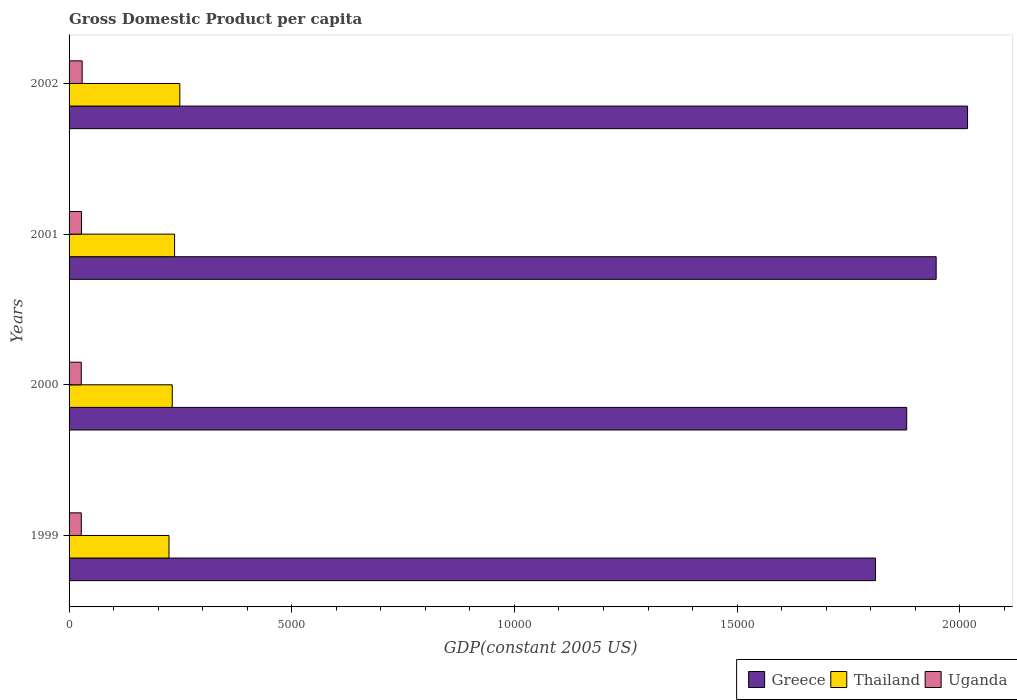How many different coloured bars are there?
Make the answer very short. 3. Are the number of bars per tick equal to the number of legend labels?
Offer a terse response. Yes. How many bars are there on the 4th tick from the top?
Keep it short and to the point. 3. What is the label of the 3rd group of bars from the top?
Offer a very short reply. 2000. In how many cases, is the number of bars for a given year not equal to the number of legend labels?
Provide a succinct answer. 0. What is the GDP per capita in Uganda in 1999?
Your response must be concise. 274.43. Across all years, what is the maximum GDP per capita in Uganda?
Your response must be concise. 293.98. Across all years, what is the minimum GDP per capita in Greece?
Your response must be concise. 1.81e+04. In which year was the GDP per capita in Uganda minimum?
Offer a terse response. 2000. What is the total GDP per capita in Greece in the graph?
Give a very brief answer. 7.66e+04. What is the difference between the GDP per capita in Greece in 2000 and that in 2001?
Offer a very short reply. -661.74. What is the difference between the GDP per capita in Uganda in 1999 and the GDP per capita in Thailand in 2002?
Provide a short and direct response. -2212.3. What is the average GDP per capita in Uganda per year?
Make the answer very short. 280.54. In the year 2002, what is the difference between the GDP per capita in Thailand and GDP per capita in Uganda?
Make the answer very short. 2192.74. What is the ratio of the GDP per capita in Greece in 2001 to that in 2002?
Your response must be concise. 0.97. Is the difference between the GDP per capita in Thailand in 2000 and 2001 greater than the difference between the GDP per capita in Uganda in 2000 and 2001?
Give a very brief answer. No. What is the difference between the highest and the second highest GDP per capita in Thailand?
Keep it short and to the point. 117.4. What is the difference between the highest and the lowest GDP per capita in Uganda?
Offer a very short reply. 19.64. Is the sum of the GDP per capita in Thailand in 1999 and 2002 greater than the maximum GDP per capita in Greece across all years?
Provide a short and direct response. No. What does the 1st bar from the top in 2002 represents?
Your response must be concise. Uganda. What does the 1st bar from the bottom in 2001 represents?
Offer a very short reply. Greece. Is it the case that in every year, the sum of the GDP per capita in Greece and GDP per capita in Uganda is greater than the GDP per capita in Thailand?
Offer a very short reply. Yes. Are all the bars in the graph horizontal?
Offer a terse response. Yes. What is the difference between two consecutive major ticks on the X-axis?
Your answer should be very brief. 5000. Are the values on the major ticks of X-axis written in scientific E-notation?
Your answer should be compact. No. Does the graph contain any zero values?
Offer a very short reply. No. Where does the legend appear in the graph?
Give a very brief answer. Bottom right. How many legend labels are there?
Provide a short and direct response. 3. How are the legend labels stacked?
Provide a succinct answer. Horizontal. What is the title of the graph?
Ensure brevity in your answer.  Gross Domestic Product per capita. Does "High income: OECD" appear as one of the legend labels in the graph?
Provide a succinct answer. No. What is the label or title of the X-axis?
Offer a very short reply. GDP(constant 2005 US). What is the label or title of the Y-axis?
Keep it short and to the point. Years. What is the GDP(constant 2005 US) of Greece in 1999?
Offer a terse response. 1.81e+04. What is the GDP(constant 2005 US) of Thailand in 1999?
Ensure brevity in your answer.  2243.74. What is the GDP(constant 2005 US) in Uganda in 1999?
Your answer should be compact. 274.43. What is the GDP(constant 2005 US) in Greece in 2000?
Your response must be concise. 1.88e+04. What is the GDP(constant 2005 US) in Thailand in 2000?
Your answer should be very brief. 2316.82. What is the GDP(constant 2005 US) in Uganda in 2000?
Keep it short and to the point. 274.34. What is the GDP(constant 2005 US) in Greece in 2001?
Your answer should be very brief. 1.95e+04. What is the GDP(constant 2005 US) of Thailand in 2001?
Ensure brevity in your answer.  2369.33. What is the GDP(constant 2005 US) in Uganda in 2001?
Give a very brief answer. 279.42. What is the GDP(constant 2005 US) of Greece in 2002?
Keep it short and to the point. 2.02e+04. What is the GDP(constant 2005 US) of Thailand in 2002?
Your answer should be very brief. 2486.73. What is the GDP(constant 2005 US) of Uganda in 2002?
Give a very brief answer. 293.98. Across all years, what is the maximum GDP(constant 2005 US) of Greece?
Offer a terse response. 2.02e+04. Across all years, what is the maximum GDP(constant 2005 US) in Thailand?
Make the answer very short. 2486.73. Across all years, what is the maximum GDP(constant 2005 US) in Uganda?
Offer a very short reply. 293.98. Across all years, what is the minimum GDP(constant 2005 US) of Greece?
Ensure brevity in your answer.  1.81e+04. Across all years, what is the minimum GDP(constant 2005 US) in Thailand?
Offer a terse response. 2243.74. Across all years, what is the minimum GDP(constant 2005 US) of Uganda?
Ensure brevity in your answer.  274.34. What is the total GDP(constant 2005 US) in Greece in the graph?
Give a very brief answer. 7.66e+04. What is the total GDP(constant 2005 US) in Thailand in the graph?
Provide a succinct answer. 9416.62. What is the total GDP(constant 2005 US) in Uganda in the graph?
Provide a succinct answer. 1122.18. What is the difference between the GDP(constant 2005 US) in Greece in 1999 and that in 2000?
Give a very brief answer. -701.13. What is the difference between the GDP(constant 2005 US) of Thailand in 1999 and that in 2000?
Your answer should be compact. -73.08. What is the difference between the GDP(constant 2005 US) in Uganda in 1999 and that in 2000?
Your response must be concise. 0.09. What is the difference between the GDP(constant 2005 US) of Greece in 1999 and that in 2001?
Ensure brevity in your answer.  -1362.88. What is the difference between the GDP(constant 2005 US) of Thailand in 1999 and that in 2001?
Your response must be concise. -125.6. What is the difference between the GDP(constant 2005 US) in Uganda in 1999 and that in 2001?
Your answer should be very brief. -4.99. What is the difference between the GDP(constant 2005 US) in Greece in 1999 and that in 2002?
Give a very brief answer. -2067.8. What is the difference between the GDP(constant 2005 US) of Thailand in 1999 and that in 2002?
Offer a very short reply. -242.99. What is the difference between the GDP(constant 2005 US) of Uganda in 1999 and that in 2002?
Your response must be concise. -19.55. What is the difference between the GDP(constant 2005 US) of Greece in 2000 and that in 2001?
Your answer should be very brief. -661.74. What is the difference between the GDP(constant 2005 US) in Thailand in 2000 and that in 2001?
Ensure brevity in your answer.  -52.52. What is the difference between the GDP(constant 2005 US) of Uganda in 2000 and that in 2001?
Your answer should be compact. -5.08. What is the difference between the GDP(constant 2005 US) of Greece in 2000 and that in 2002?
Your answer should be very brief. -1366.67. What is the difference between the GDP(constant 2005 US) of Thailand in 2000 and that in 2002?
Offer a very short reply. -169.91. What is the difference between the GDP(constant 2005 US) of Uganda in 2000 and that in 2002?
Your answer should be compact. -19.64. What is the difference between the GDP(constant 2005 US) of Greece in 2001 and that in 2002?
Provide a short and direct response. -704.93. What is the difference between the GDP(constant 2005 US) in Thailand in 2001 and that in 2002?
Your response must be concise. -117.4. What is the difference between the GDP(constant 2005 US) of Uganda in 2001 and that in 2002?
Ensure brevity in your answer.  -14.56. What is the difference between the GDP(constant 2005 US) in Greece in 1999 and the GDP(constant 2005 US) in Thailand in 2000?
Provide a short and direct response. 1.58e+04. What is the difference between the GDP(constant 2005 US) in Greece in 1999 and the GDP(constant 2005 US) in Uganda in 2000?
Your answer should be compact. 1.78e+04. What is the difference between the GDP(constant 2005 US) in Thailand in 1999 and the GDP(constant 2005 US) in Uganda in 2000?
Offer a very short reply. 1969.4. What is the difference between the GDP(constant 2005 US) of Greece in 1999 and the GDP(constant 2005 US) of Thailand in 2001?
Offer a very short reply. 1.57e+04. What is the difference between the GDP(constant 2005 US) in Greece in 1999 and the GDP(constant 2005 US) in Uganda in 2001?
Make the answer very short. 1.78e+04. What is the difference between the GDP(constant 2005 US) of Thailand in 1999 and the GDP(constant 2005 US) of Uganda in 2001?
Make the answer very short. 1964.31. What is the difference between the GDP(constant 2005 US) of Greece in 1999 and the GDP(constant 2005 US) of Thailand in 2002?
Make the answer very short. 1.56e+04. What is the difference between the GDP(constant 2005 US) of Greece in 1999 and the GDP(constant 2005 US) of Uganda in 2002?
Make the answer very short. 1.78e+04. What is the difference between the GDP(constant 2005 US) of Thailand in 1999 and the GDP(constant 2005 US) of Uganda in 2002?
Make the answer very short. 1949.75. What is the difference between the GDP(constant 2005 US) of Greece in 2000 and the GDP(constant 2005 US) of Thailand in 2001?
Provide a short and direct response. 1.64e+04. What is the difference between the GDP(constant 2005 US) in Greece in 2000 and the GDP(constant 2005 US) in Uganda in 2001?
Provide a succinct answer. 1.85e+04. What is the difference between the GDP(constant 2005 US) of Thailand in 2000 and the GDP(constant 2005 US) of Uganda in 2001?
Provide a succinct answer. 2037.4. What is the difference between the GDP(constant 2005 US) of Greece in 2000 and the GDP(constant 2005 US) of Thailand in 2002?
Offer a terse response. 1.63e+04. What is the difference between the GDP(constant 2005 US) in Greece in 2000 and the GDP(constant 2005 US) in Uganda in 2002?
Give a very brief answer. 1.85e+04. What is the difference between the GDP(constant 2005 US) of Thailand in 2000 and the GDP(constant 2005 US) of Uganda in 2002?
Give a very brief answer. 2022.83. What is the difference between the GDP(constant 2005 US) in Greece in 2001 and the GDP(constant 2005 US) in Thailand in 2002?
Provide a succinct answer. 1.70e+04. What is the difference between the GDP(constant 2005 US) of Greece in 2001 and the GDP(constant 2005 US) of Uganda in 2002?
Make the answer very short. 1.92e+04. What is the difference between the GDP(constant 2005 US) of Thailand in 2001 and the GDP(constant 2005 US) of Uganda in 2002?
Offer a terse response. 2075.35. What is the average GDP(constant 2005 US) in Greece per year?
Your answer should be very brief. 1.91e+04. What is the average GDP(constant 2005 US) of Thailand per year?
Keep it short and to the point. 2354.15. What is the average GDP(constant 2005 US) in Uganda per year?
Give a very brief answer. 280.54. In the year 1999, what is the difference between the GDP(constant 2005 US) of Greece and GDP(constant 2005 US) of Thailand?
Make the answer very short. 1.59e+04. In the year 1999, what is the difference between the GDP(constant 2005 US) of Greece and GDP(constant 2005 US) of Uganda?
Provide a short and direct response. 1.78e+04. In the year 1999, what is the difference between the GDP(constant 2005 US) in Thailand and GDP(constant 2005 US) in Uganda?
Provide a short and direct response. 1969.31. In the year 2000, what is the difference between the GDP(constant 2005 US) in Greece and GDP(constant 2005 US) in Thailand?
Offer a terse response. 1.65e+04. In the year 2000, what is the difference between the GDP(constant 2005 US) in Greece and GDP(constant 2005 US) in Uganda?
Provide a succinct answer. 1.85e+04. In the year 2000, what is the difference between the GDP(constant 2005 US) in Thailand and GDP(constant 2005 US) in Uganda?
Your answer should be compact. 2042.48. In the year 2001, what is the difference between the GDP(constant 2005 US) in Greece and GDP(constant 2005 US) in Thailand?
Your response must be concise. 1.71e+04. In the year 2001, what is the difference between the GDP(constant 2005 US) of Greece and GDP(constant 2005 US) of Uganda?
Your response must be concise. 1.92e+04. In the year 2001, what is the difference between the GDP(constant 2005 US) in Thailand and GDP(constant 2005 US) in Uganda?
Keep it short and to the point. 2089.91. In the year 2002, what is the difference between the GDP(constant 2005 US) in Greece and GDP(constant 2005 US) in Thailand?
Offer a very short reply. 1.77e+04. In the year 2002, what is the difference between the GDP(constant 2005 US) in Greece and GDP(constant 2005 US) in Uganda?
Offer a very short reply. 1.99e+04. In the year 2002, what is the difference between the GDP(constant 2005 US) in Thailand and GDP(constant 2005 US) in Uganda?
Offer a terse response. 2192.74. What is the ratio of the GDP(constant 2005 US) in Greece in 1999 to that in 2000?
Give a very brief answer. 0.96. What is the ratio of the GDP(constant 2005 US) in Thailand in 1999 to that in 2000?
Offer a terse response. 0.97. What is the ratio of the GDP(constant 2005 US) of Thailand in 1999 to that in 2001?
Your response must be concise. 0.95. What is the ratio of the GDP(constant 2005 US) in Uganda in 1999 to that in 2001?
Ensure brevity in your answer.  0.98. What is the ratio of the GDP(constant 2005 US) in Greece in 1999 to that in 2002?
Give a very brief answer. 0.9. What is the ratio of the GDP(constant 2005 US) of Thailand in 1999 to that in 2002?
Your response must be concise. 0.9. What is the ratio of the GDP(constant 2005 US) in Uganda in 1999 to that in 2002?
Provide a short and direct response. 0.93. What is the ratio of the GDP(constant 2005 US) in Thailand in 2000 to that in 2001?
Make the answer very short. 0.98. What is the ratio of the GDP(constant 2005 US) in Uganda in 2000 to that in 2001?
Ensure brevity in your answer.  0.98. What is the ratio of the GDP(constant 2005 US) of Greece in 2000 to that in 2002?
Offer a very short reply. 0.93. What is the ratio of the GDP(constant 2005 US) in Thailand in 2000 to that in 2002?
Ensure brevity in your answer.  0.93. What is the ratio of the GDP(constant 2005 US) in Uganda in 2000 to that in 2002?
Your response must be concise. 0.93. What is the ratio of the GDP(constant 2005 US) in Greece in 2001 to that in 2002?
Offer a terse response. 0.97. What is the ratio of the GDP(constant 2005 US) of Thailand in 2001 to that in 2002?
Provide a succinct answer. 0.95. What is the ratio of the GDP(constant 2005 US) of Uganda in 2001 to that in 2002?
Keep it short and to the point. 0.95. What is the difference between the highest and the second highest GDP(constant 2005 US) of Greece?
Ensure brevity in your answer.  704.93. What is the difference between the highest and the second highest GDP(constant 2005 US) of Thailand?
Keep it short and to the point. 117.4. What is the difference between the highest and the second highest GDP(constant 2005 US) in Uganda?
Offer a very short reply. 14.56. What is the difference between the highest and the lowest GDP(constant 2005 US) of Greece?
Your response must be concise. 2067.8. What is the difference between the highest and the lowest GDP(constant 2005 US) in Thailand?
Provide a short and direct response. 242.99. What is the difference between the highest and the lowest GDP(constant 2005 US) of Uganda?
Give a very brief answer. 19.64. 